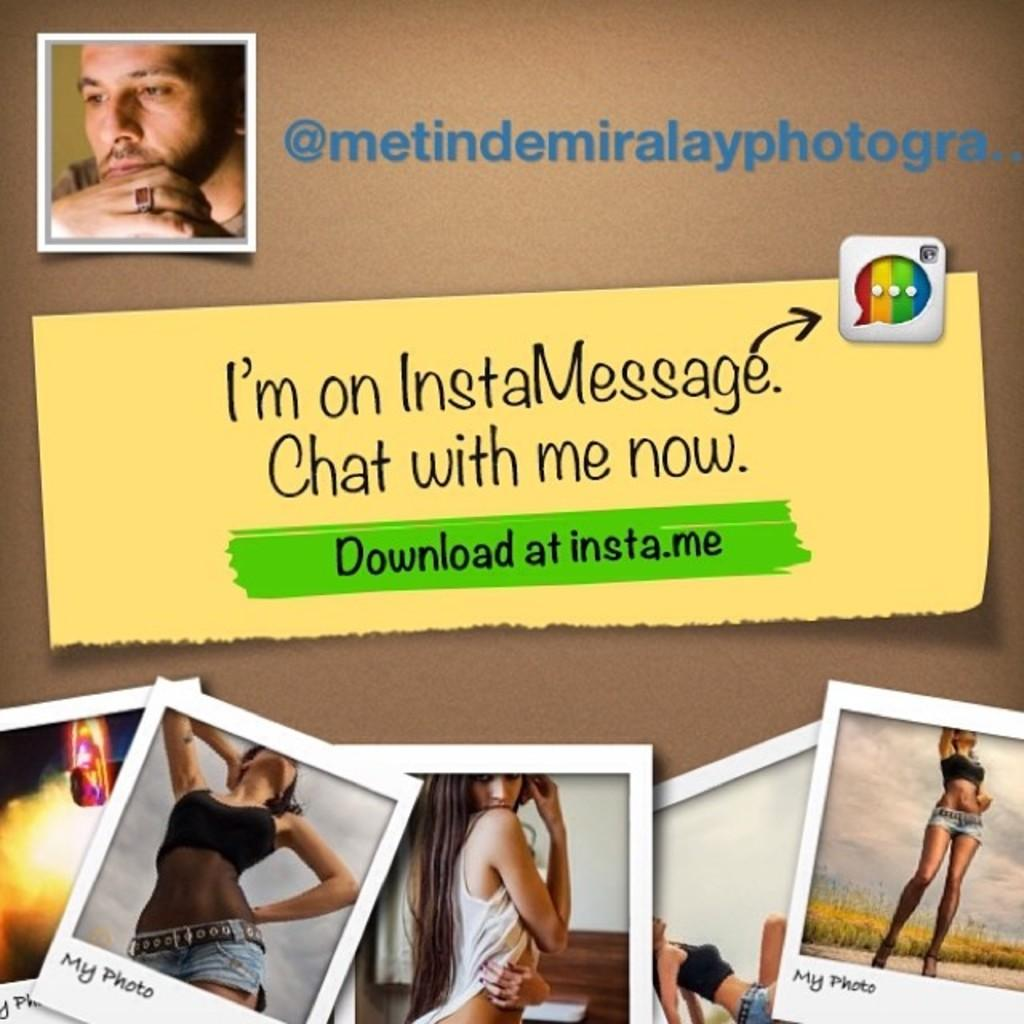What can be observed about the nature of the image? The image is edited. What types of visual elements are present in the image? There are pictures and text in the image. How many kittens are visible in the image? There are no kittens present in the image. What type of food is being bitten in the image? There is no food or act of biting depicted in the image. 